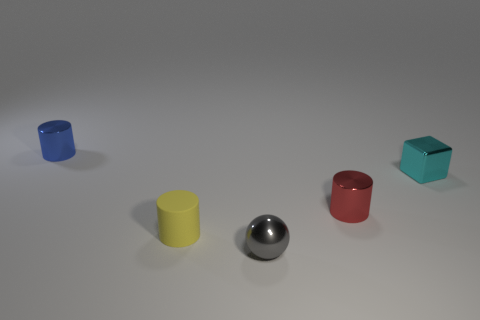What is the size of the shiny thing on the left side of the tiny shiny object that is in front of the rubber cylinder?
Your response must be concise. Small. What number of red cylinders are the same size as the ball?
Ensure brevity in your answer.  1. Is the color of the tiny metallic cylinder that is right of the tiny blue metallic thing the same as the metal object in front of the small rubber thing?
Keep it short and to the point. No. Are there any blue metallic things in front of the small gray ball?
Your answer should be compact. No. The object that is both behind the small gray shiny object and in front of the small red thing is what color?
Keep it short and to the point. Yellow. Is there another small cube of the same color as the tiny metal cube?
Provide a short and direct response. No. Do the blue cylinder that is left of the matte object and the small cylinder that is right of the gray shiny object have the same material?
Offer a very short reply. Yes. There is a cyan thing right of the yellow cylinder; what size is it?
Your answer should be compact. Small. What is the size of the red cylinder?
Offer a terse response. Small. How big is the metallic cylinder in front of the small metallic cylinder that is behind the small metallic cylinder on the right side of the small blue cylinder?
Provide a short and direct response. Small. 